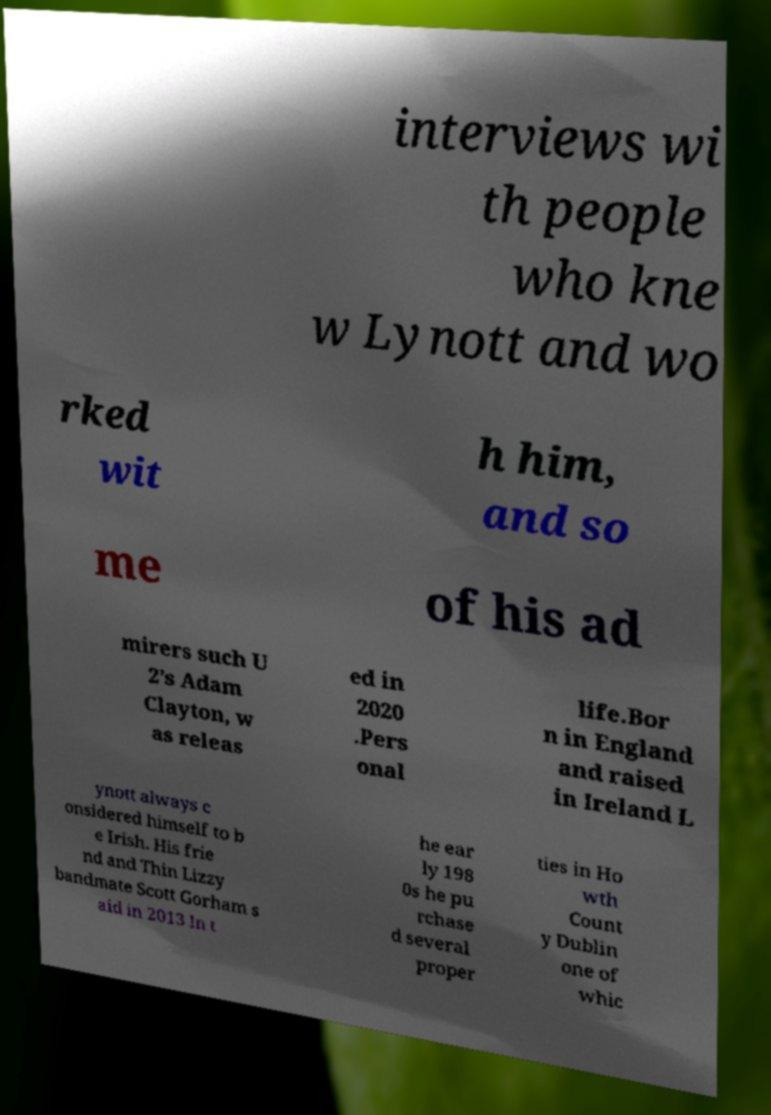Could you extract and type out the text from this image? interviews wi th people who kne w Lynott and wo rked wit h him, and so me of his ad mirers such U 2’s Adam Clayton, w as releas ed in 2020 .Pers onal life.Bor n in England and raised in Ireland L ynott always c onsidered himself to b e Irish. His frie nd and Thin Lizzy bandmate Scott Gorham s aid in 2013 In t he ear ly 198 0s he pu rchase d several proper ties in Ho wth Count y Dublin one of whic 